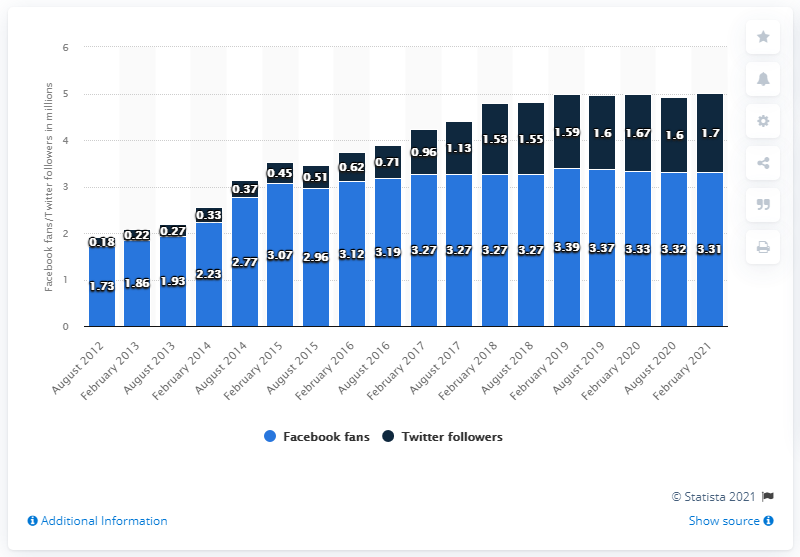Identify some key points in this picture. In February 2021, the Las Vegas Raiders football team had 3.31 million Facebook followers. 